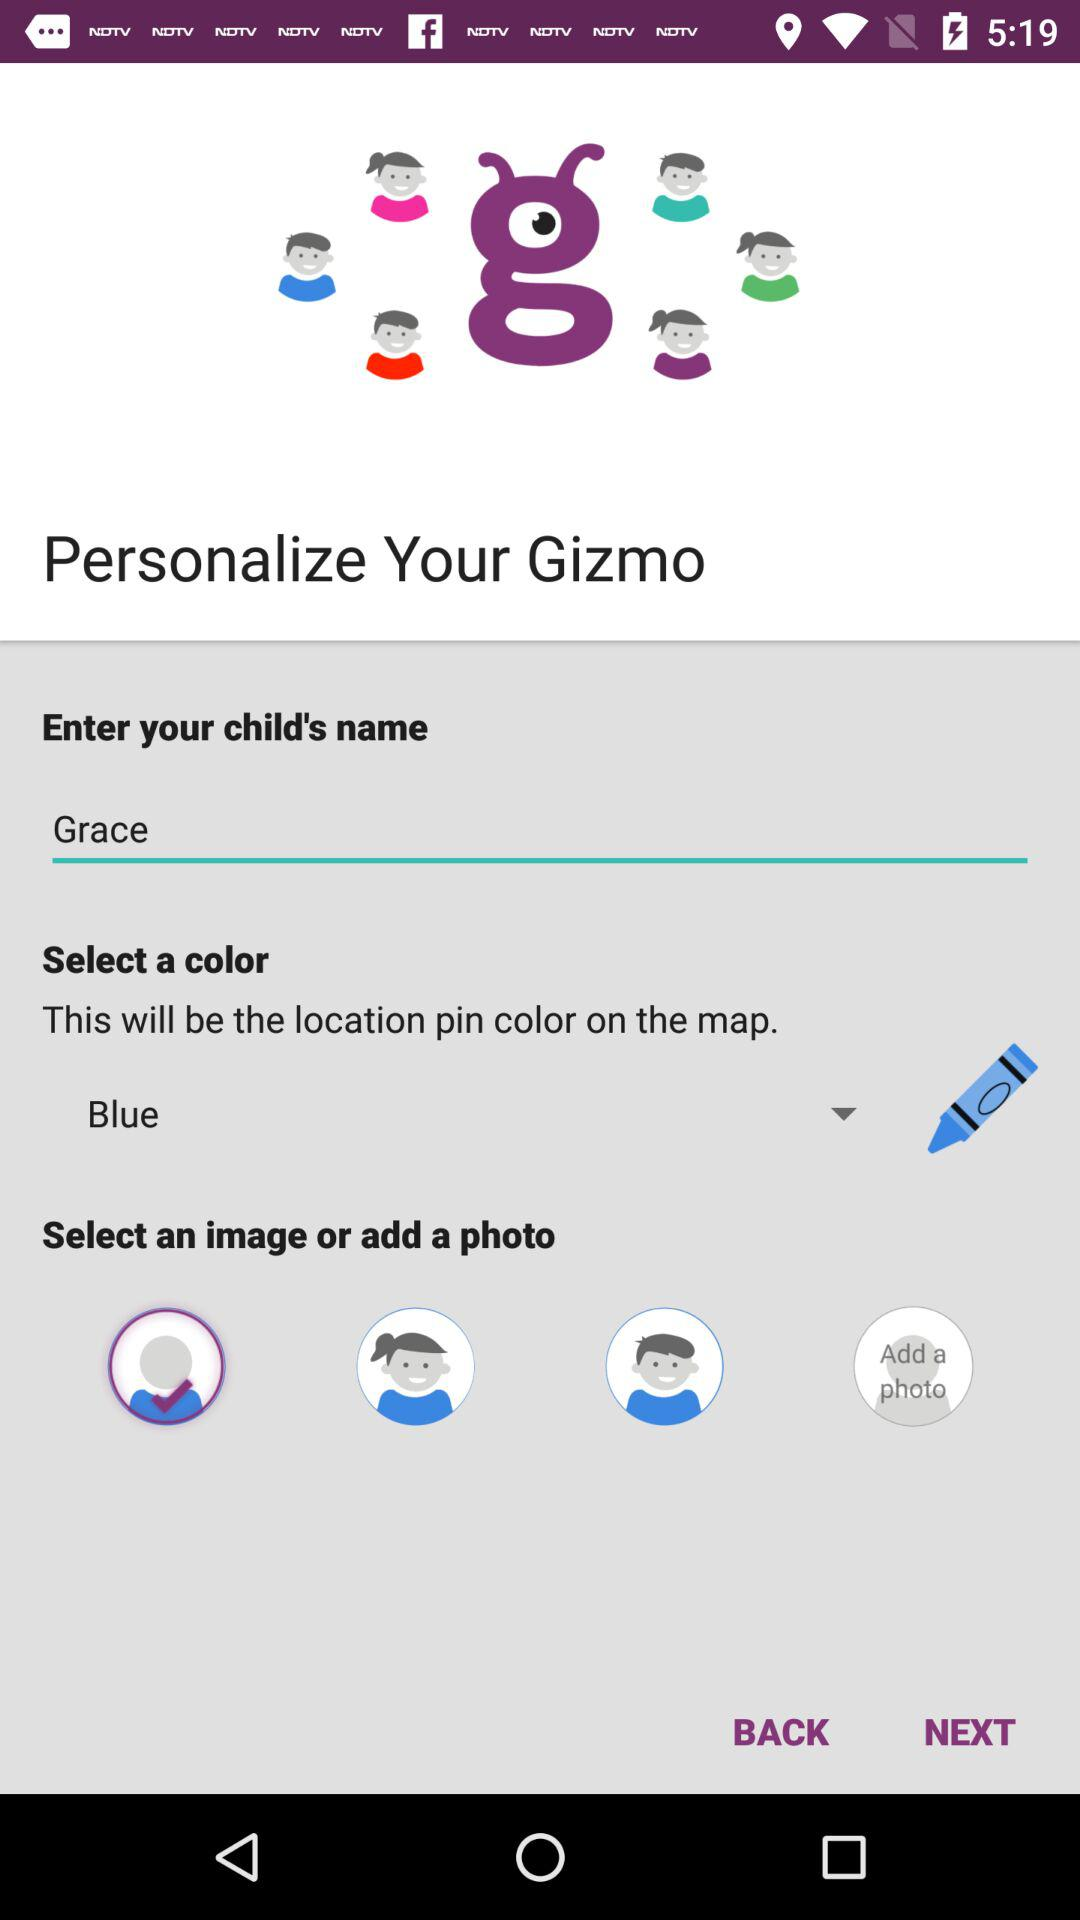Which color is selected? The selected color is blue. 